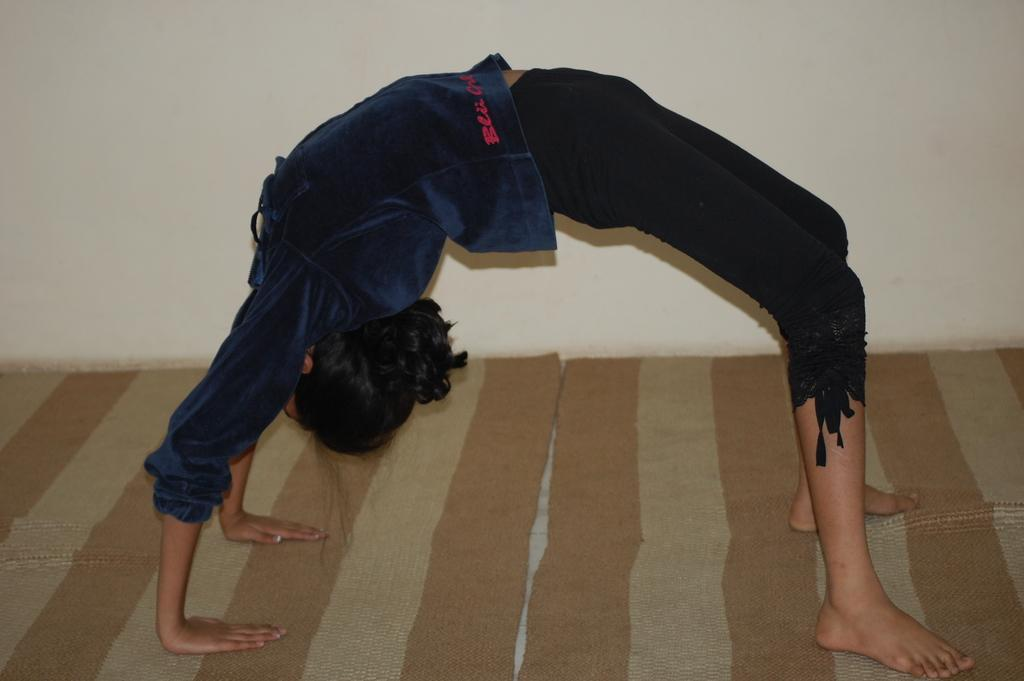Who is the main subject in the image? There is a woman in the image. What is the woman wearing? The woman is wearing a blue shirt. What activity is the woman engaged in? The woman is performing yoga on the floor. What type of flooring is visible in the image? There are carpets on the floor. What can be seen in the background of the image? There is a wall in the background of the image. What type of pies can be seen on the stage in the image? There is no stage or pies present in the image; it features a woman performing yoga on a carpeted floor. 